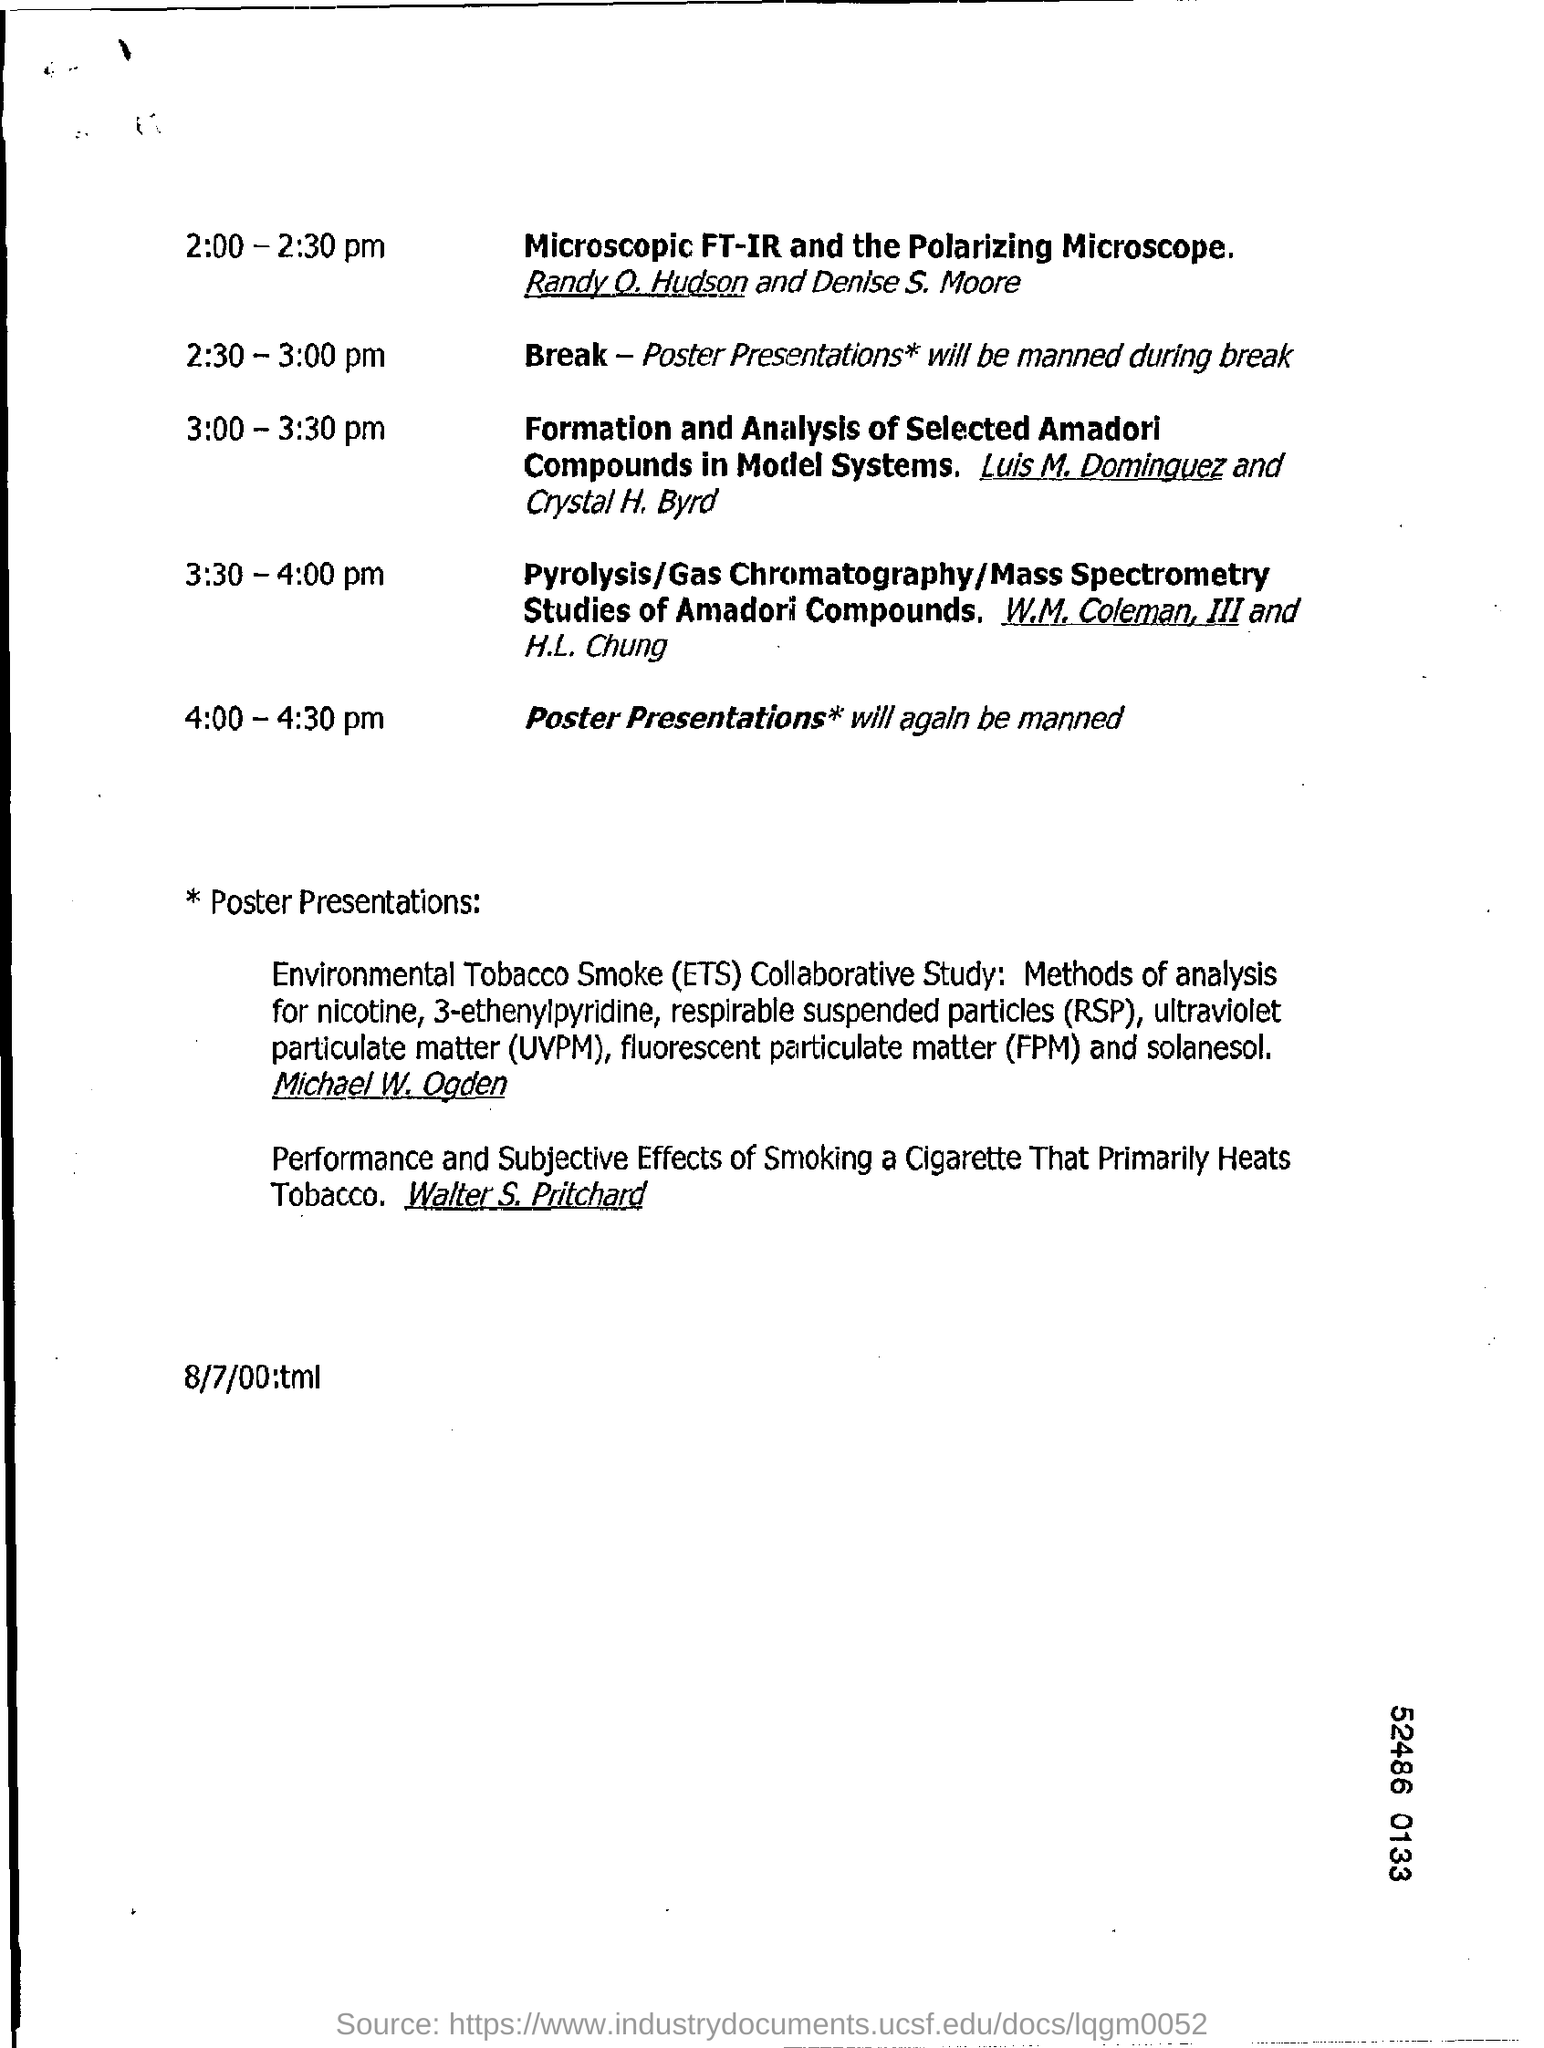What is the full form of rsp?
Provide a short and direct response. Respirable suspended particles. What is the acronym of fpm?
Offer a terse response. Fluorescent Particulate Matter. 